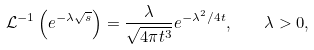<formula> <loc_0><loc_0><loc_500><loc_500>\mathcal { L } ^ { - 1 } \left ( e ^ { - \lambda \sqrt { s } } \right ) = \frac { \lambda } { \sqrt { 4 \pi t ^ { 3 } } } e ^ { - \lambda ^ { 2 } / 4 t } , \quad \lambda > 0 ,</formula> 